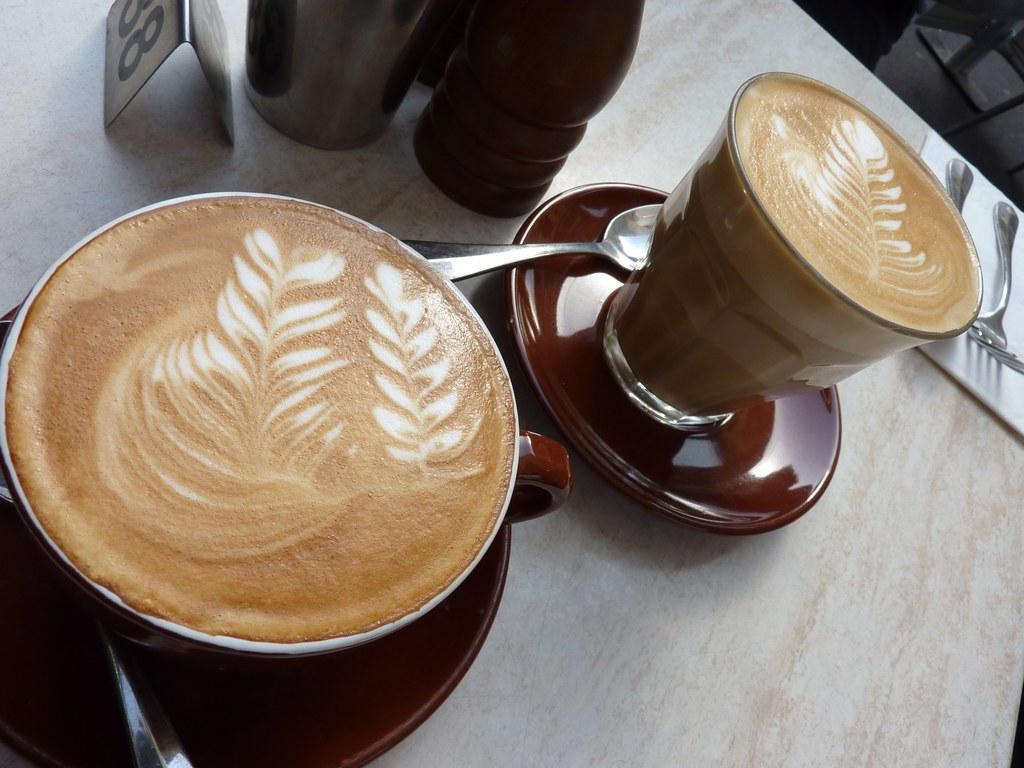How many cups are visible in the image? There are 2 cups in the image. What other items are present in the image that match the number of cups? There are 2 saucers, 2 spoons, and 2 forks in the image. What type of balloon is floating above the cups in the image? There is no balloon present in the image. Are there any ants visible on the cups or saucers in the image? There is no mention of ants in the image. Is there a protest happening in the image involving the cups and saucers? There is no protest or any indication of a protest in the image. 